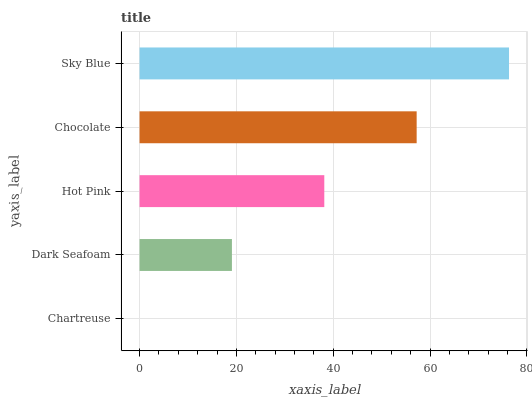Is Chartreuse the minimum?
Answer yes or no. Yes. Is Sky Blue the maximum?
Answer yes or no. Yes. Is Dark Seafoam the minimum?
Answer yes or no. No. Is Dark Seafoam the maximum?
Answer yes or no. No. Is Dark Seafoam greater than Chartreuse?
Answer yes or no. Yes. Is Chartreuse less than Dark Seafoam?
Answer yes or no. Yes. Is Chartreuse greater than Dark Seafoam?
Answer yes or no. No. Is Dark Seafoam less than Chartreuse?
Answer yes or no. No. Is Hot Pink the high median?
Answer yes or no. Yes. Is Hot Pink the low median?
Answer yes or no. Yes. Is Chartreuse the high median?
Answer yes or no. No. Is Chocolate the low median?
Answer yes or no. No. 